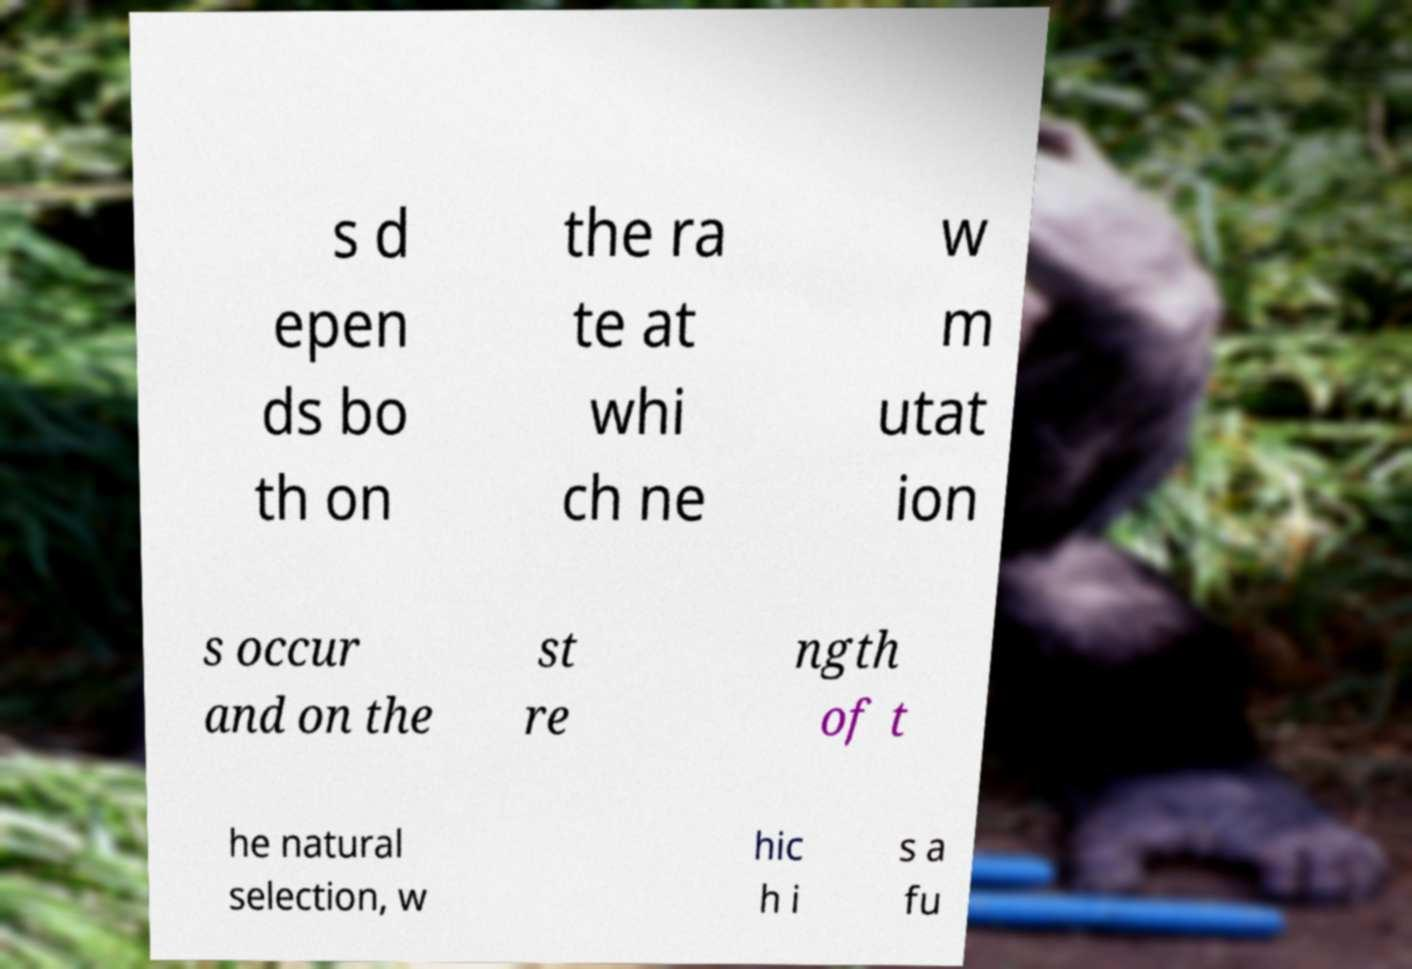What messages or text are displayed in this image? I need them in a readable, typed format. s d epen ds bo th on the ra te at whi ch ne w m utat ion s occur and on the st re ngth of t he natural selection, w hic h i s a fu 